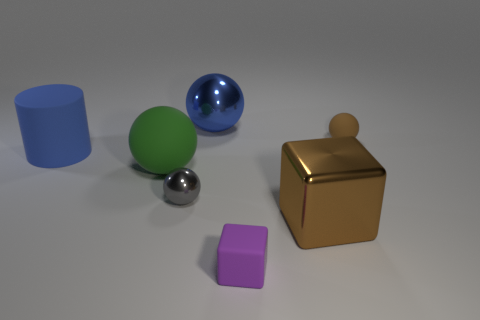How many blocks have the same size as the cylinder?
Your answer should be compact. 1. Is the tiny matte ball the same color as the tiny metal thing?
Ensure brevity in your answer.  No. Is the big blue thing that is left of the tiny gray thing made of the same material as the brown thing behind the green matte thing?
Your answer should be very brief. Yes. Are there more gray metal things than tiny red matte cylinders?
Provide a short and direct response. Yes. Are there any other things that are the same color as the cylinder?
Provide a succinct answer. Yes. Does the purple block have the same material as the cylinder?
Give a very brief answer. Yes. Are there fewer matte cubes than red spheres?
Offer a terse response. No. Is the shape of the green matte object the same as the big brown thing?
Provide a succinct answer. No. What color is the small matte ball?
Offer a terse response. Brown. What number of other objects are there of the same material as the gray sphere?
Your answer should be very brief. 2. 